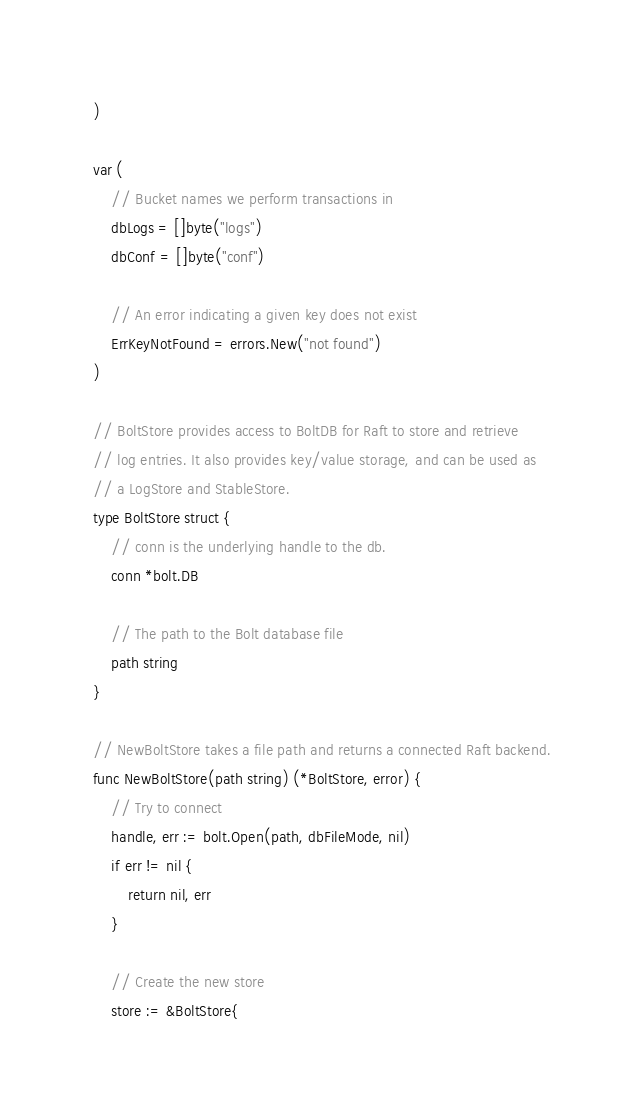<code> <loc_0><loc_0><loc_500><loc_500><_Go_>)

var (
	// Bucket names we perform transactions in
	dbLogs = []byte("logs")
	dbConf = []byte("conf")

	// An error indicating a given key does not exist
	ErrKeyNotFound = errors.New("not found")
)

// BoltStore provides access to BoltDB for Raft to store and retrieve
// log entries. It also provides key/value storage, and can be used as
// a LogStore and StableStore.
type BoltStore struct {
	// conn is the underlying handle to the db.
	conn *bolt.DB

	// The path to the Bolt database file
	path string
}

// NewBoltStore takes a file path and returns a connected Raft backend.
func NewBoltStore(path string) (*BoltStore, error) {
	// Try to connect
	handle, err := bolt.Open(path, dbFileMode, nil)
	if err != nil {
		return nil, err
	}

	// Create the new store
	store := &BoltStore{</code> 